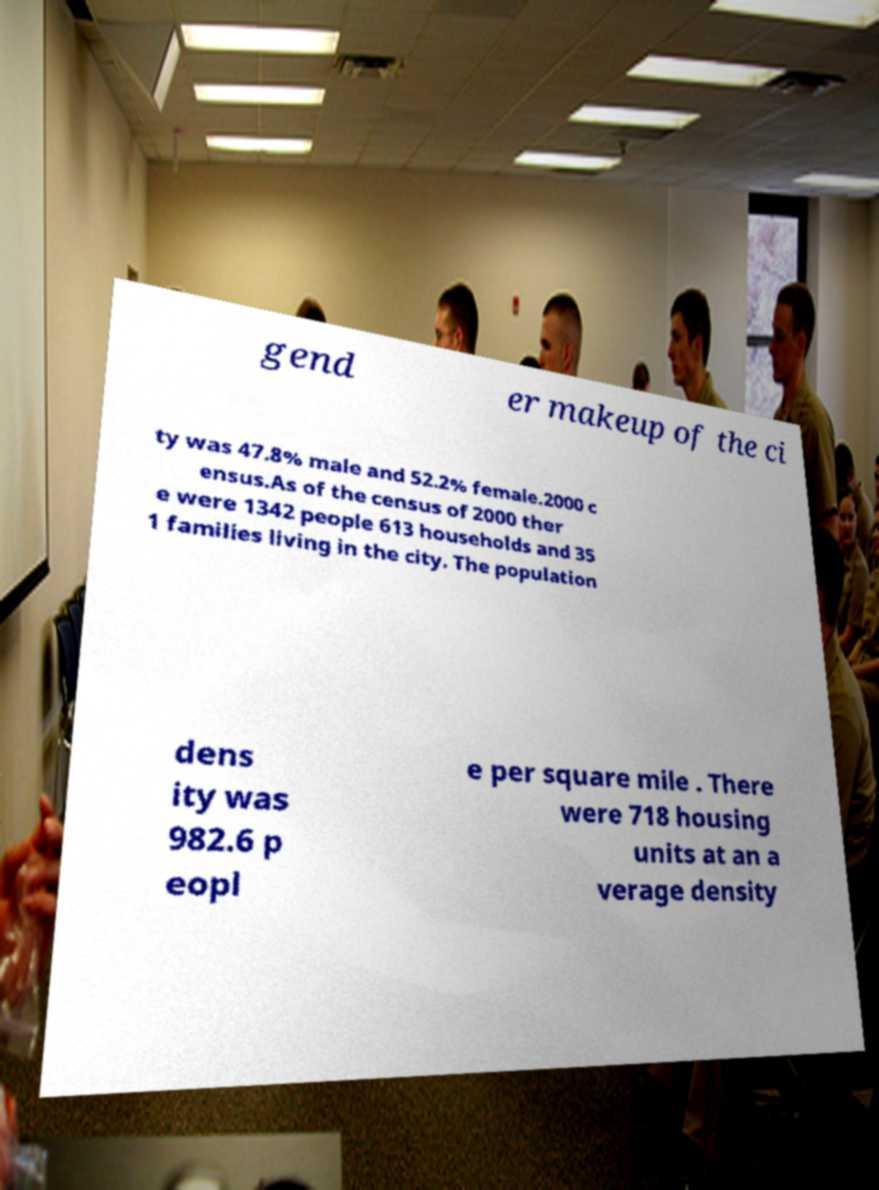Please identify and transcribe the text found in this image. gend er makeup of the ci ty was 47.8% male and 52.2% female.2000 c ensus.As of the census of 2000 ther e were 1342 people 613 households and 35 1 families living in the city. The population dens ity was 982.6 p eopl e per square mile . There were 718 housing units at an a verage density 